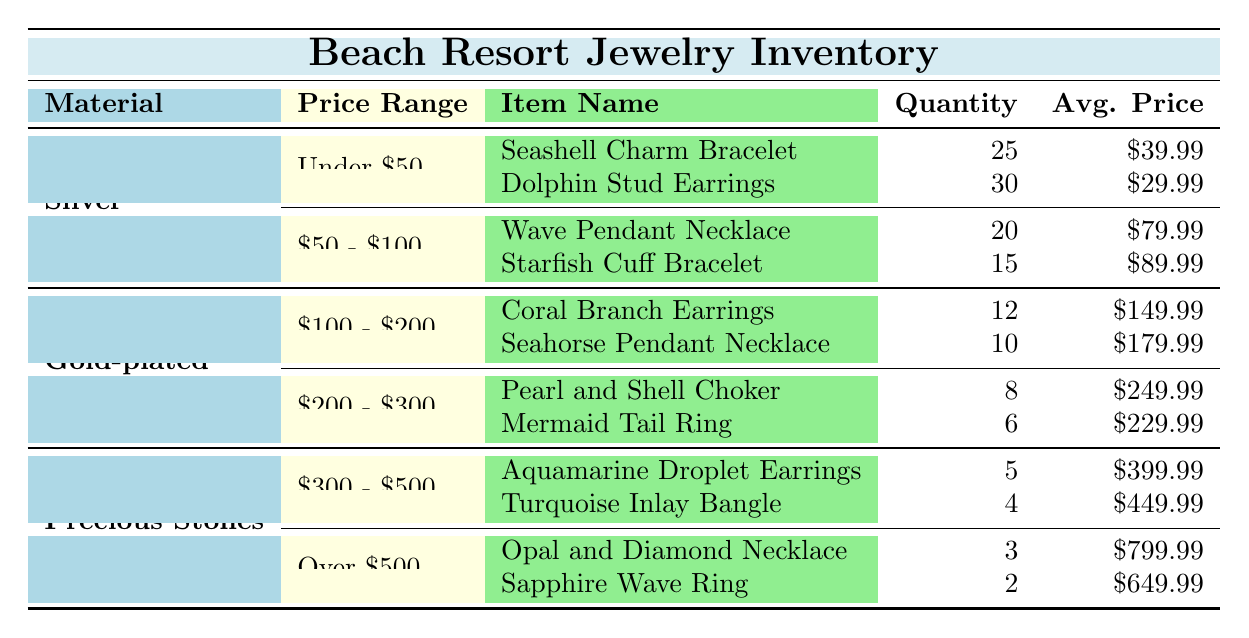What jewelry items are available under the price range of $50? According to the table, the items listed under the price range of under $50 are the Seashell Charm Bracelet and the Dolphin Stud Earrings.
Answer: Seashell Charm Bracelet, Dolphin Stud Earrings How many Dolphin Stud Earrings are in inventory? The table shows that the quantity for Dolphin Stud Earrings is 30.
Answer: 30 What is the average price of the Silver jewelry items? For Silver jewelry, the average prices are $39.99 (Seashell Charm Bracelet), $29.99 (Dolphin Stud Earrings), $79.99 (Wave Pendant Necklace), and $89.99 (Starfish Cuff Bracelet). Calculating the average: (39.99 + 29.99 + 79.99 + 89.99) / 4 = $59.99.
Answer: $59.99 Which material has the least quantity of items available? Looking at the table, Precious Stones has the least quantity of items available: Aquamarine Droplet Earrings (5) and Turquoise Inlay Bangle (4), together totaling 9. Comparatively, Silver has 25+30+20+15=90, and Gold-plated has 12+10+8+6=36. Therefore, Precious Stones has the least quantity.
Answer: Precious Stones Are there any Gold-plated items priced above $200? The table lists two Gold-plated items in the price range of $200 - $300: Pearl and Shell Choker ($249.99) and Mermaid Tail Ring ($229.99). Thus, yes, there are items priced above $200.
Answer: Yes What is the total quantity of Silver jewelry items in the inventory? For Silver, the quantities are 25 (Seashell Charm Bracelet) + 30 (Dolphin Stud Earrings) + 20 (Wave Pendant Necklace) + 15 (Starfish Cuff Bracelet), totaling 90.
Answer: 90 Which item has the highest average price and what is that price? The item with the highest average price in the table is the Opal and Diamond Necklace at $799.99.
Answer: Opal and Diamond Necklace, $799.99 How many items of Precious Stones are there priced below $500? Under the price range of $300 - $500, there are Aquamarine Droplet Earrings (5) and Turquoise Inlay Bangle (4), totaling 9 items.
Answer: 9 Which price range has the most items in terms of quantity? Checking the total quantities: Under $50 has 25 + 30 = 55; $50 - $100 has 20 + 15 = 35; $100 - $200 has 12 + 10 = 22; $200 - $300 has 8 + 6 = 14; $300 - $500 has 5 + 4 = 9; Over $500 has 3 + 2 = 5. The under $50 range has the most with 55 items.
Answer: Under $50 Is there a pattern in the pricing of jewelry items as the quality of material increases? As seen in the table, the average prices of items rise as the material changes from Silver, Gold-plated to Precious Stones. Silver items range from under $100, Gold-plated items range from $100 to $300, and Precious Stones items start from $300. Therefore, there is a pattern of increasing price with higher material quality.
Answer: Yes 